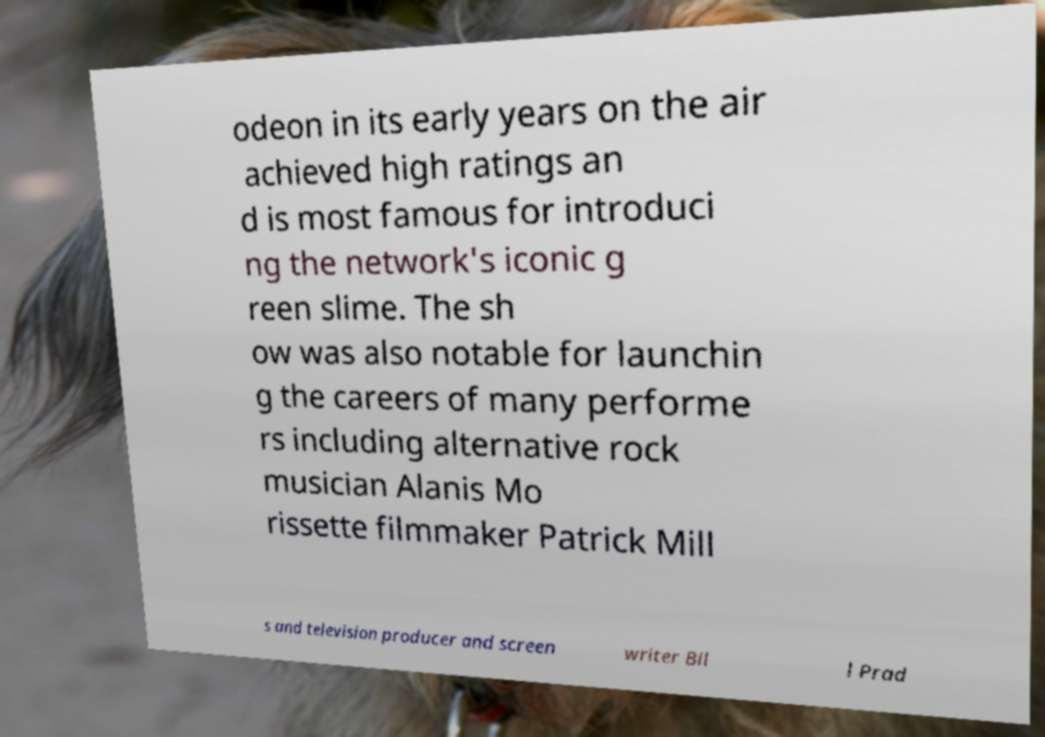Could you extract and type out the text from this image? odeon in its early years on the air achieved high ratings an d is most famous for introduci ng the network's iconic g reen slime. The sh ow was also notable for launchin g the careers of many performe rs including alternative rock musician Alanis Mo rissette filmmaker Patrick Mill s and television producer and screen writer Bil l Prad 